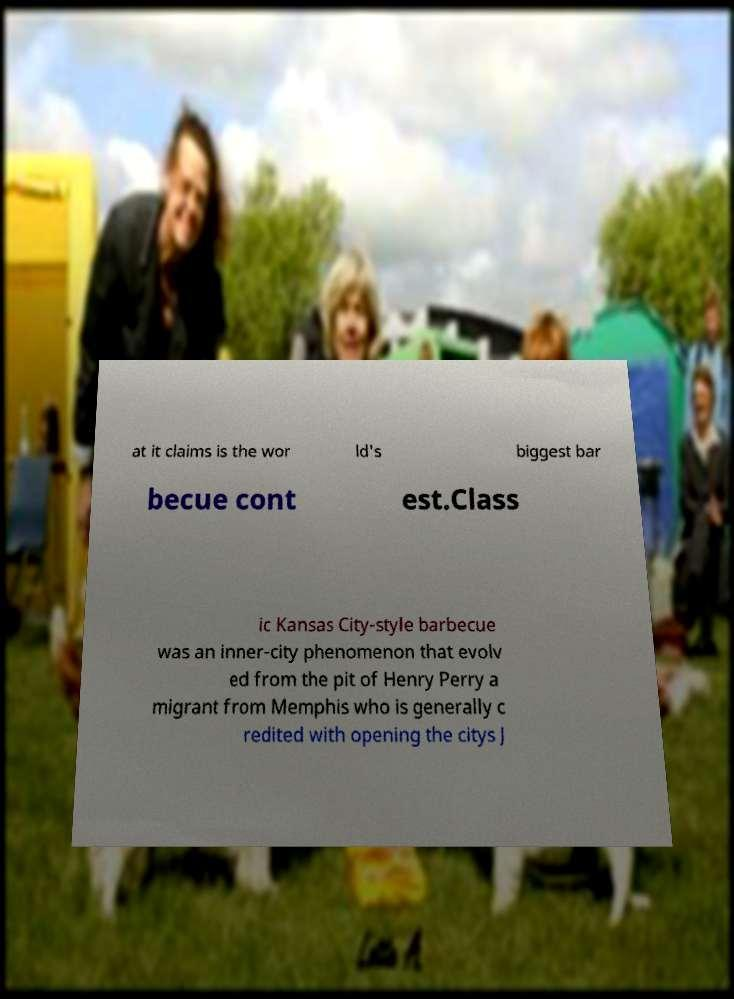Could you assist in decoding the text presented in this image and type it out clearly? at it claims is the wor ld's biggest bar becue cont est.Class ic Kansas City-style barbecue was an inner-city phenomenon that evolv ed from the pit of Henry Perry a migrant from Memphis who is generally c redited with opening the citys J 